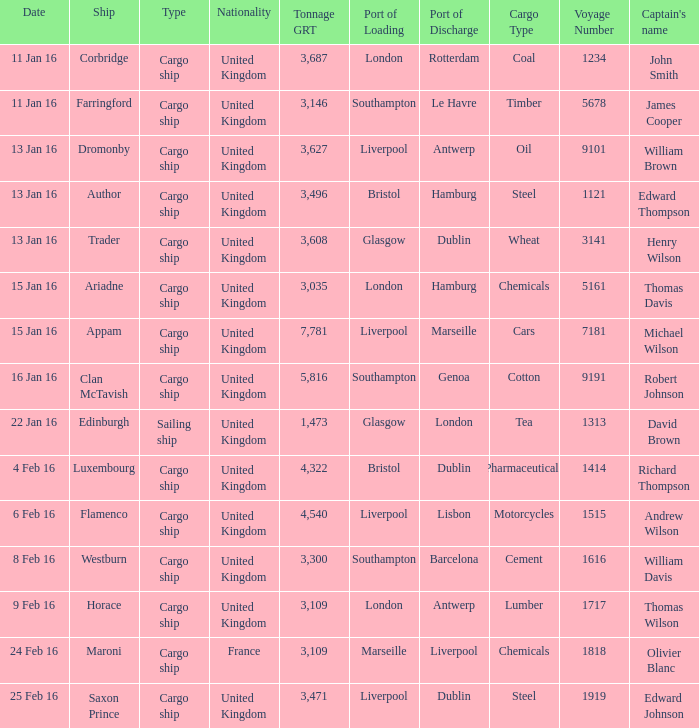What is the tonnage grt of the ship author? 3496.0. 